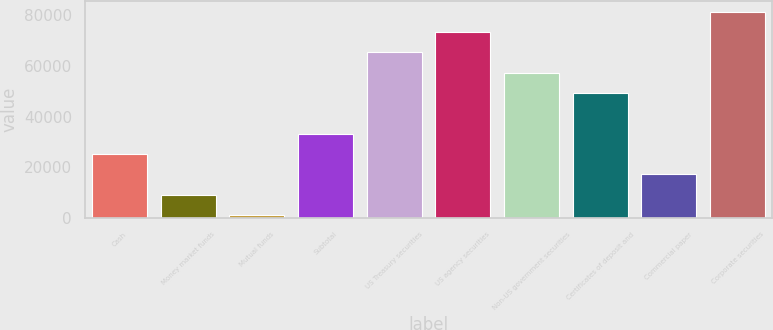<chart> <loc_0><loc_0><loc_500><loc_500><bar_chart><fcel>Cash<fcel>Money market funds<fcel>Mutual funds<fcel>Subtotal<fcel>US Treasury securities<fcel>US agency securities<fcel>Non-US government securities<fcel>Certificates of deposit and<fcel>Commercial paper<fcel>Corporate securities<nl><fcel>25298.1<fcel>9250.7<fcel>1227<fcel>33321.8<fcel>65416.6<fcel>73440.3<fcel>57392.9<fcel>49369.2<fcel>17274.4<fcel>81464<nl></chart> 